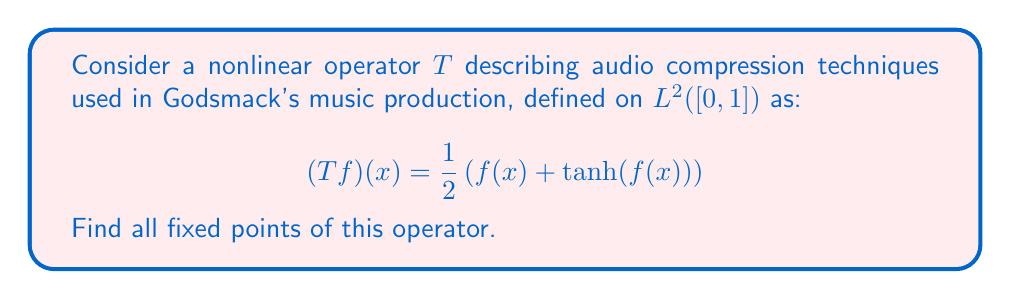Give your solution to this math problem. To find the fixed points of the operator $T$, we need to solve the equation $Tf = f$. This means:

$$f(x) = \frac{1}{2}\left(f(x) + \tanh(f(x))\right)$$

Let's solve this equation step by step:

1) First, let's isolate $\tanh(f(x))$:
   
   $$2f(x) = f(x) + \tanh(f(x))$$
   $$f(x) = \tanh(f(x))$$

2) Now, we need to solve $y = \tanh(y)$. Let's consider the properties of $\tanh$:
   
   - $\tanh(0) = 0$
   - $\tanh(y)$ is an odd function, so if $y$ is a solution, $-y$ is also a solution
   - $|\tanh(y)| < 1$ for all $y \neq 0$

3) From these properties, we can deduce that:
   
   - $y = 0$ is always a solution
   - For $y \neq 0$, we must have $|y| < 1$ (because $|\tanh(y)| < 1$)
   - But for $0 < |y| < 1$, we always have $|\tanh(y)| < |y|$

4) Therefore, the only solution to $y = \tanh(y)$ is $y = 0$.

5) Translating this back to our original problem, the only fixed point of $T$ is the constant function $f(x) = 0$ for all $x \in [0,1]$.

This result aligns with the concept of audio compression, where the goal is often to reduce the dynamic range of the audio signal, effectively "compressing" it towards zero.
Answer: The only fixed point of the operator $T$ is the constant function $f(x) = 0$ for all $x \in [0,1]$. 